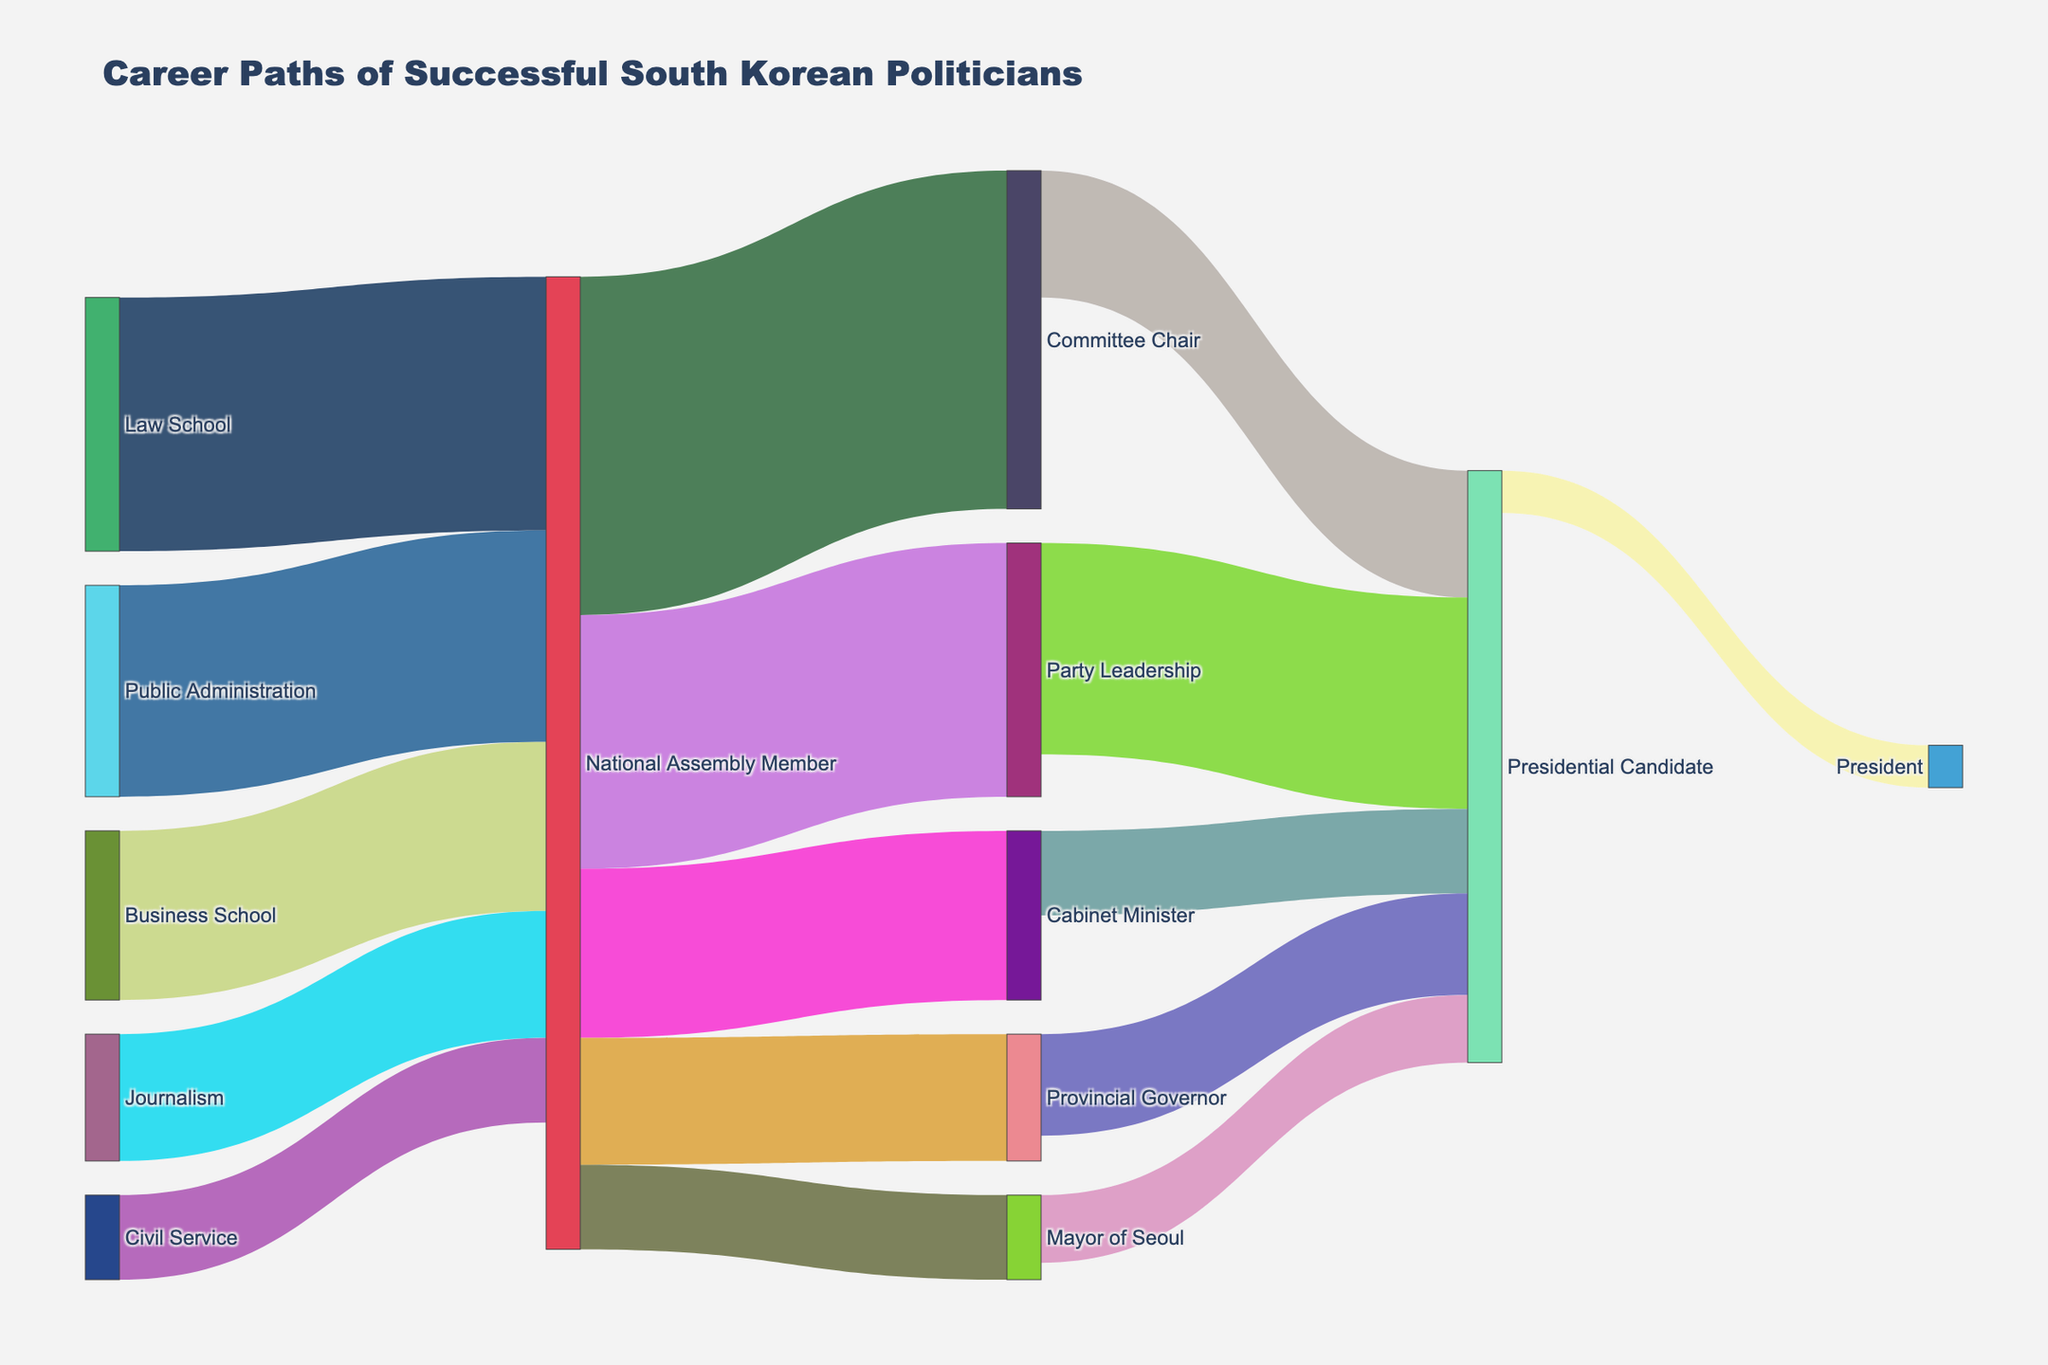How many career paths are leading to the position of Presidential Candidate? By inspecting the figure, we observe paths leading from Committee Chair, Party Leadership, Cabinet Minister, Mayor of Seoul, and Provincial Governor to the Presidential Candidate. Summing these paths: 5.
Answer: 5 What is the most common initial career path for National Assembly Members? The figure shows inputs to the National Assembly Member from Law School, Business School, Public Administration, Journalism, and Civil Service. By comparing values: Law School (30), Business School (20), Public Administration (25), Journalism (15), Civil Service (10). The highest value is from Law School.
Answer: Law School Which position has the highest number of candidates who later become Presidents? From the figure, the Presidential Candidate node has incoming arrows from Committee Chair (15), Party Leadership (25), Cabinet Minister (10), Mayor of Seoul (8), and Provincial Governor (12). Summing these values indicates all candidates for President are Presidential Candidates. Thus, Presidential Candidate has the highest number leading to President.
Answer: Presidential Candidate How many career transitions end up with the role of Mayor of Seoul? We only see one direct input arrow leading to Mayor of Seoul from National Assembly Member, which is 10.
Answer: 1 What are the top two paths leading to the role of Presidential Candidate when ranked by their incoming values? The figure shows the paths and values leading to Presidential Candidate as follows: Committee Chair (15), Party Leadership (25), Cabinet Minister (10), Mayor of Seoul (8), and Provincial Governor (12). Ranking these, we get: Party Leadership (25) and Provincial Governor (12).
Answer: Party Leadership and Provincial Governor Which path to the Presidential Candidate role has the least number of participants? By inspecting the figure, we observe the incoming connections to Presidential Candidate: Committee Chair (15), Party Leadership (25), Cabinet Minister (10), Mayor of Seoul (8), and Provincial Governor (12). The lowest value is from Mayor of Seoul (8).
Answer: Mayor of Seoul How many National Assembly Members transition into the role of Cabinet Minister? We look at the value of the arrow directing from National Assembly Member to Cabinet Minister which is 20.
Answer: 20 From which roles do Provincial Governors come? Inspecting the figure, we see only one source arrow leading to Provincial Governor from National Assembly Member with a value of 15.
Answer: National Assembly Member 